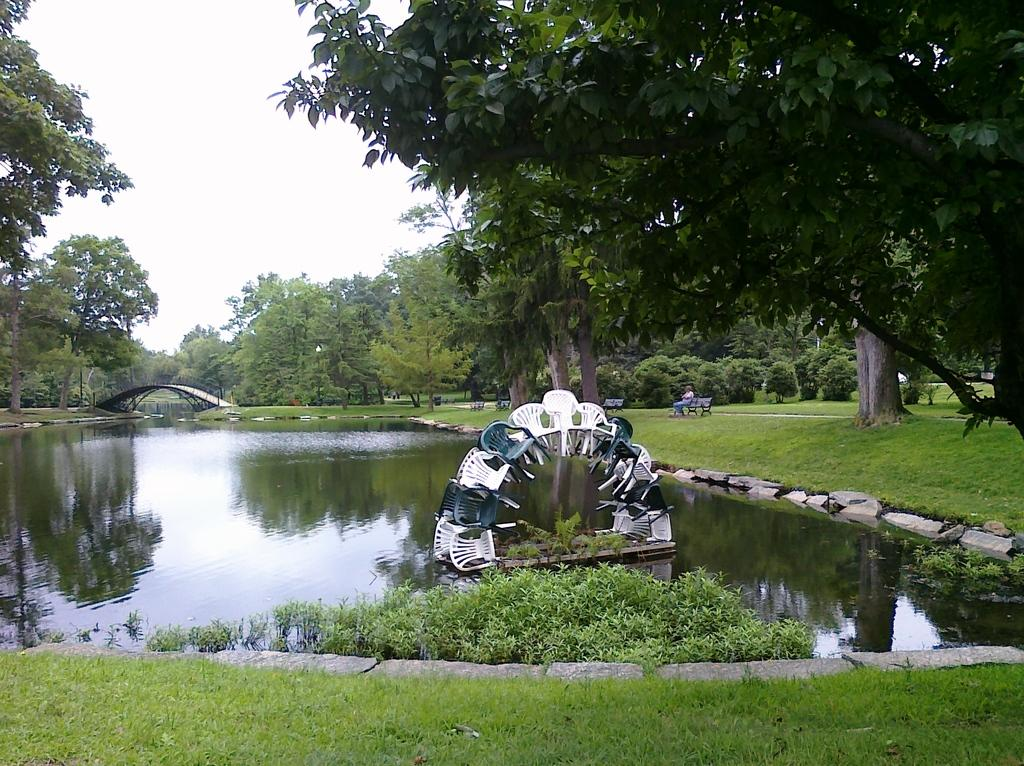What type of furniture can be seen in the image? There are chairs and benches in the image. What natural element is visible in the image? There is water, grass, stones, trees, and a bridge in the image. Where is the person located in the image? There is a person beside the water in the image. What is visible in the background of the image? The sky is visible in the background of the image. What type of sense can be seen in the image? There is no sense present in the image; it is a visual representation of a scene. Are there any cobwebs visible in the image? There are no cobwebs present in the image. 